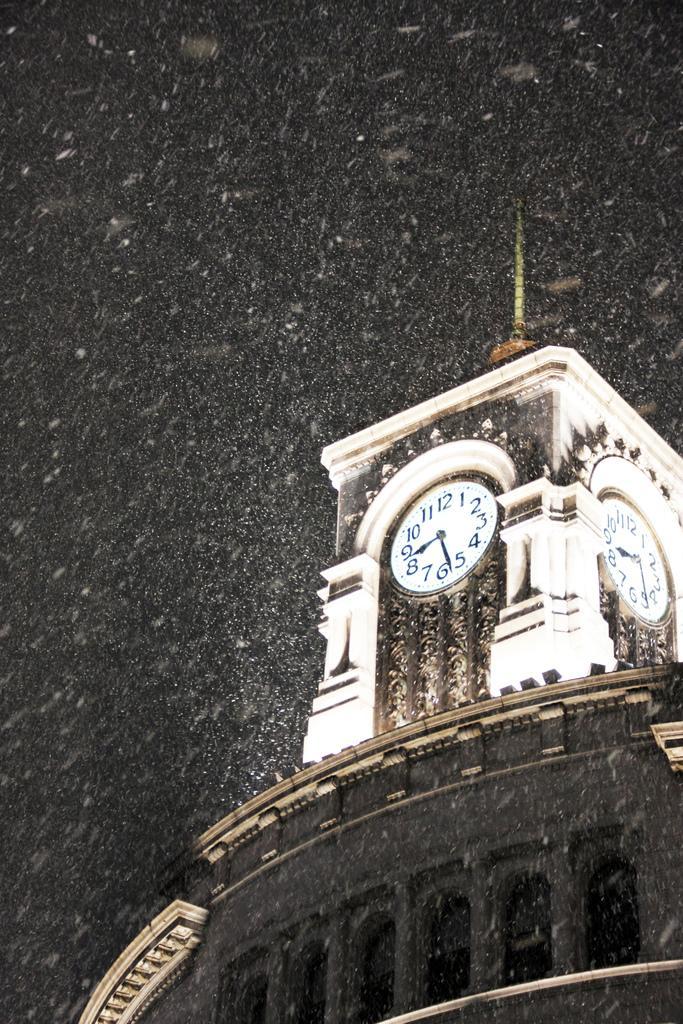Can you describe this image briefly? In this picture we see a clock tower building with snow falling on it. The sky is dark. 